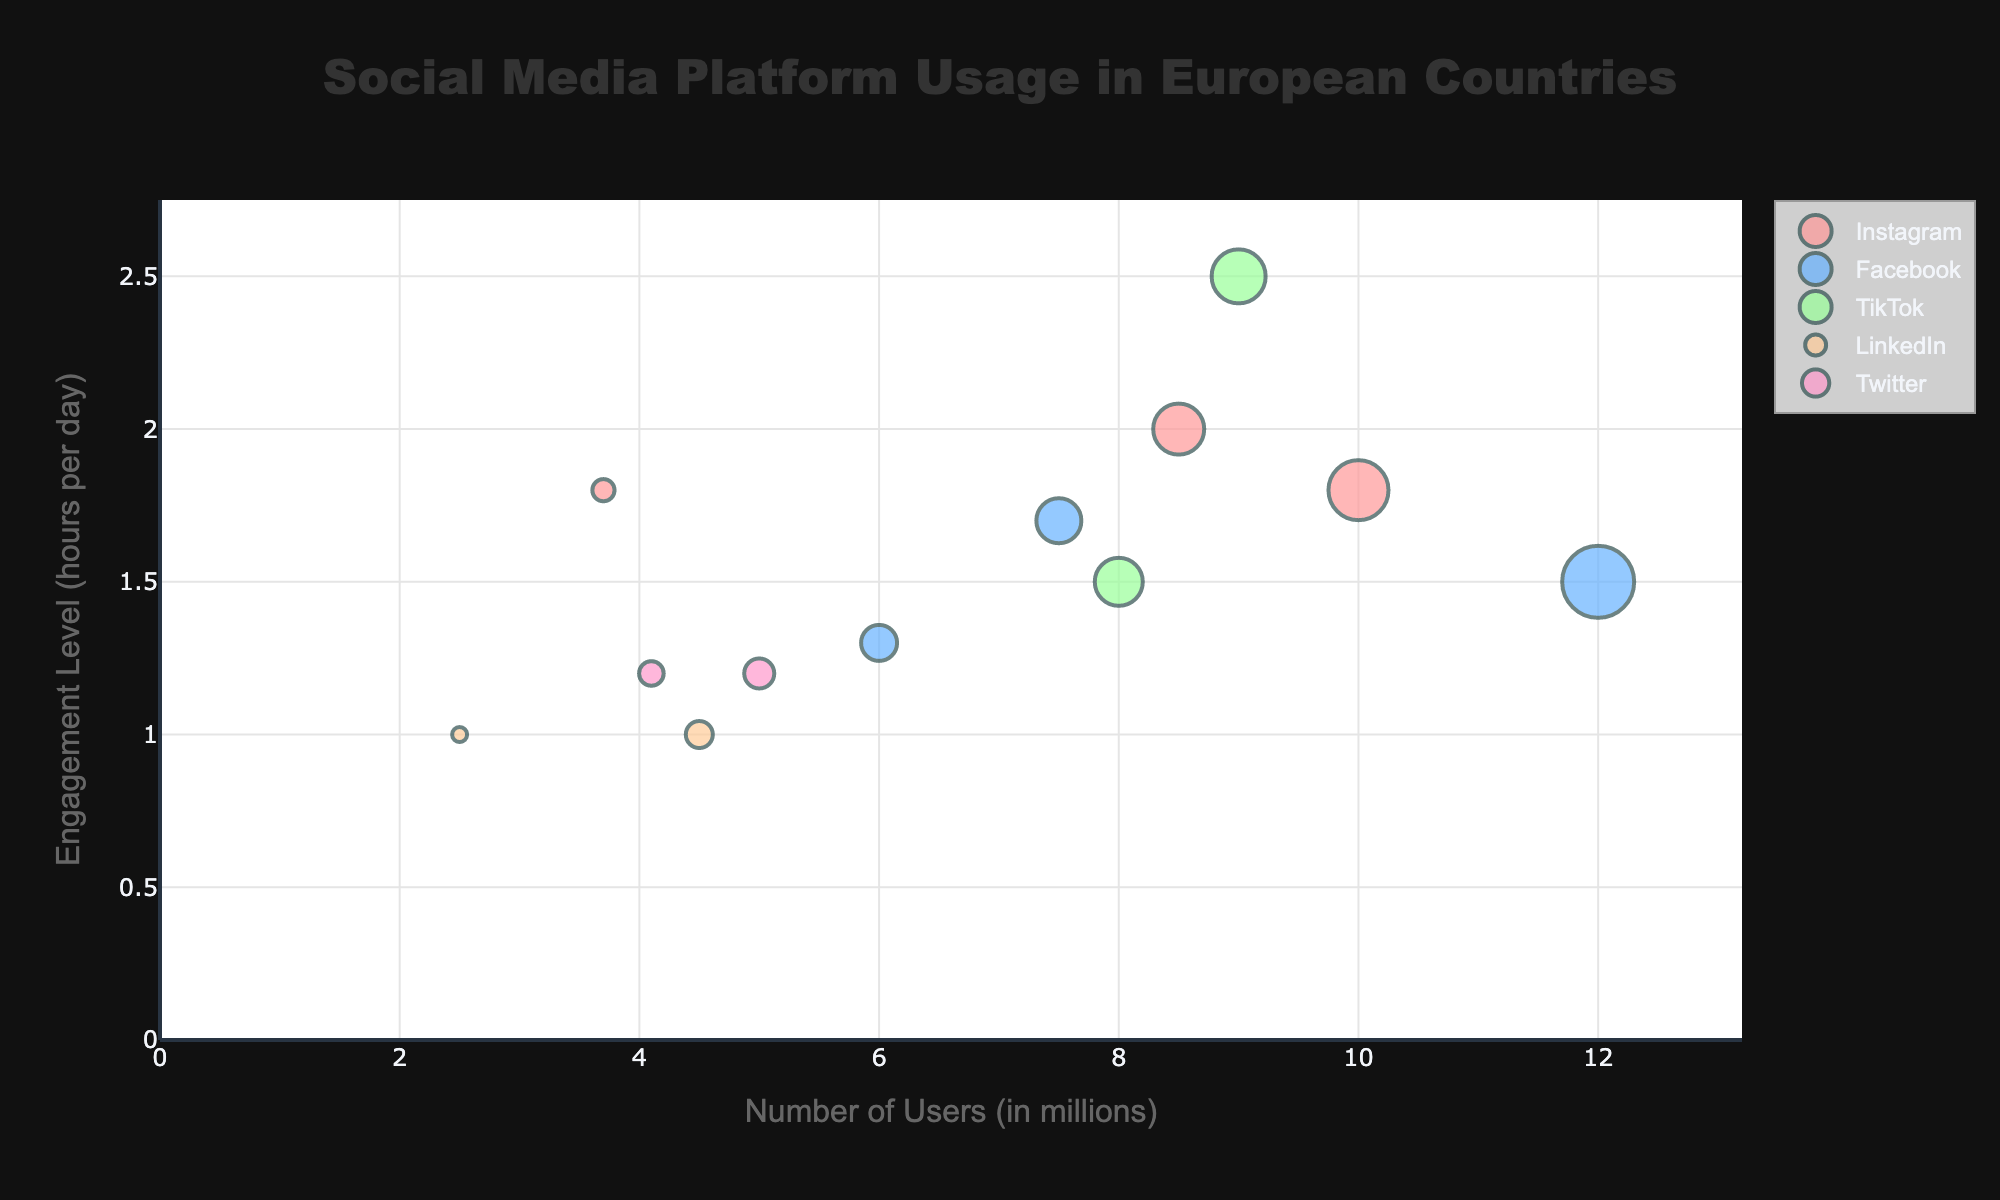What is the title of the chart? The title of the chart is found at the top and it clearly states the focus of the visual representation.
Answer: Social Media Platform Usage in European Countries Which country has the highest number of users for any platform? Look for the bubble that extends furthest along the x-axis, which indicates the highest number of users. Identify the country linked to that bubble.
Answer: France (25-34, Facebook) Which platform has the highest engagement level? Observe the bubbles that stretch highest above the y-axis to determine which platform reaches the maximum y-value (Engagement Level in hours per day).
Answer: Germany (18-24, TikTok) What is the engagement level for Instagram users aged 18-24 in France? Find the bubble for Instagram in France for the 18-24 age group and look at its y-position (Engagement Level).
Answer: 2 hours per day How many platforms have over 6 million users in any age group? Count the number of bubbles positioned beyond the 6 million mark on the x-axis. Each bubble represents a different platform.
Answer: 6 platforms How does the engagement level of TikTok users aged 25-34 in Italy compare to 18-24 year-old TikTok users in Germany? Locate the bubbles for TikTok in Italy (25-34) and Germany (18-24) and compare their y-positions (Engagement Level).
Answer: Italy (1.5) is less than Germany (2.5) Which age group has more engagement on LinkedIn in the Netherlands? Compare the y-values of the bubbles representing LinkedIn in the Netherlands for different age groups.
Answer: 18-24 years (1 hour/day), same as 25-34 years (1 hour/day) Which platform and age group have the fewest users among the data presented? Identify the smallest bubble, indicating the fewest users, by its size and confirm with x-axis value.
Answer: Netherlands (18-24, LinkedIn) What is the difference in engagement levels between Instagram users aged 18-24 in France and Spain? Subtract the engagement level (y-value) of Instagram's bubble in France (18-24) from the engagement level of Spain's bubble for the same platform and age group.
Answer: France = 2, Spain = 1.8; Difference = 0.2 hours/day Which platform appears most frequently in this dataset? Count the number of bubbles for each platform to see which one appears the most times.
Answer: Facebook (3 times) 